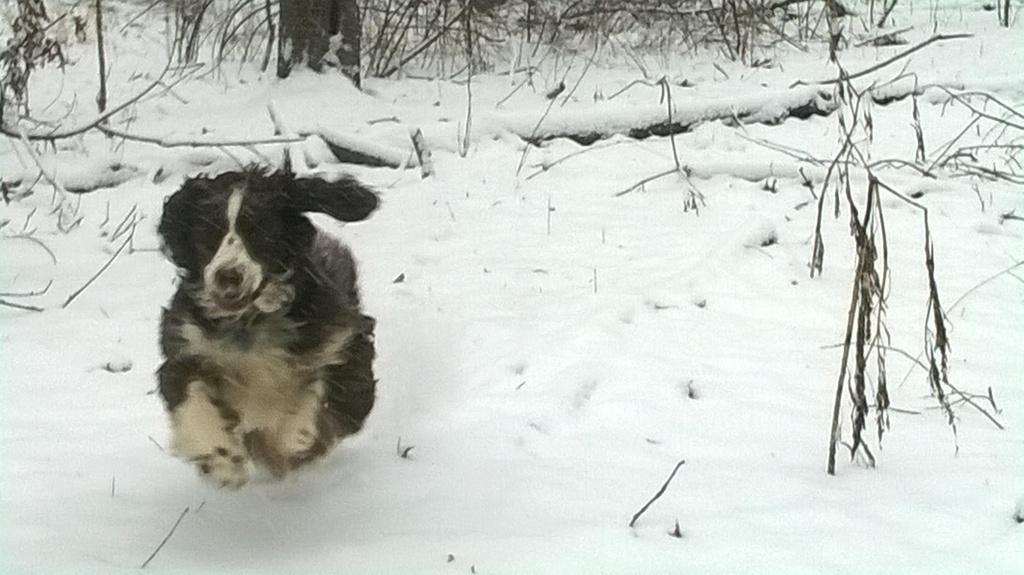What animal can be seen in the image? There is a dog in the image. What is the dog doing in the image? The dog is running in the snow. What type of vegetation is present in the image? There are trees in the image. What else can be seen on the snow in the image? There are stems on the snow. What is the primary characteristic of the image's surface? The surface of the image is covered in snow. What type of yarn is being used by the dog in the image? There is no yarn present in the image. 